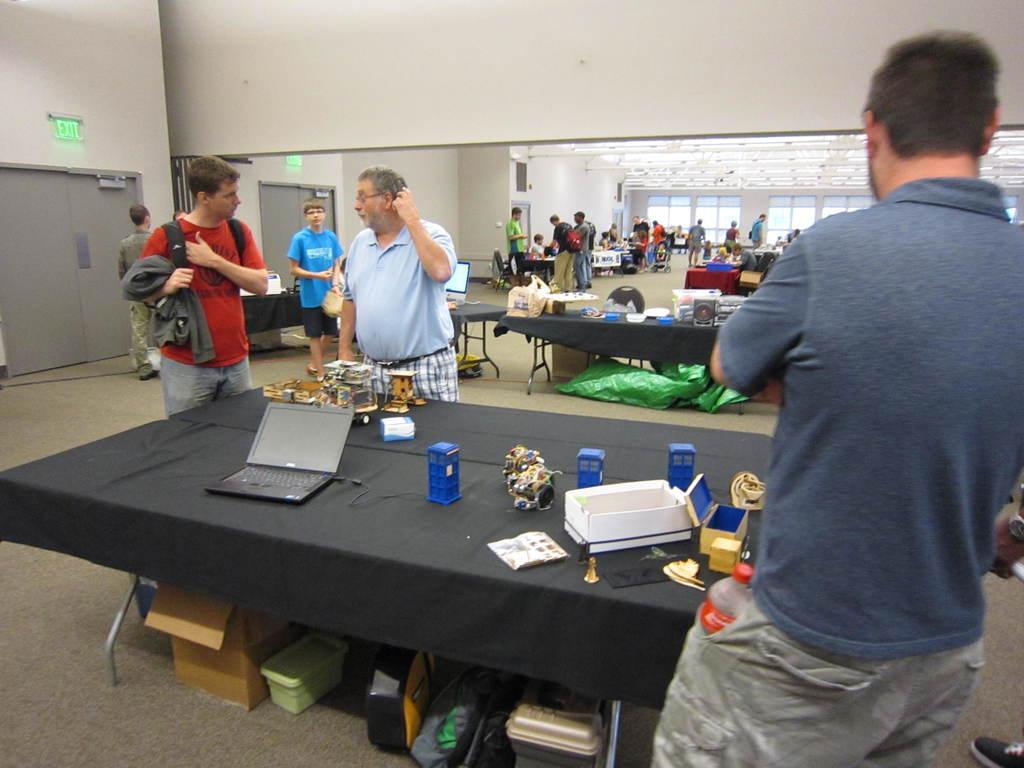How would you summarize this image in a sentence or two? Few persons are standing. A far few persons sitting on the chair. We can see tables. On the table we can see laptop,paper,box and things. This is floor. We can see boxes. On the background we can see wall. 